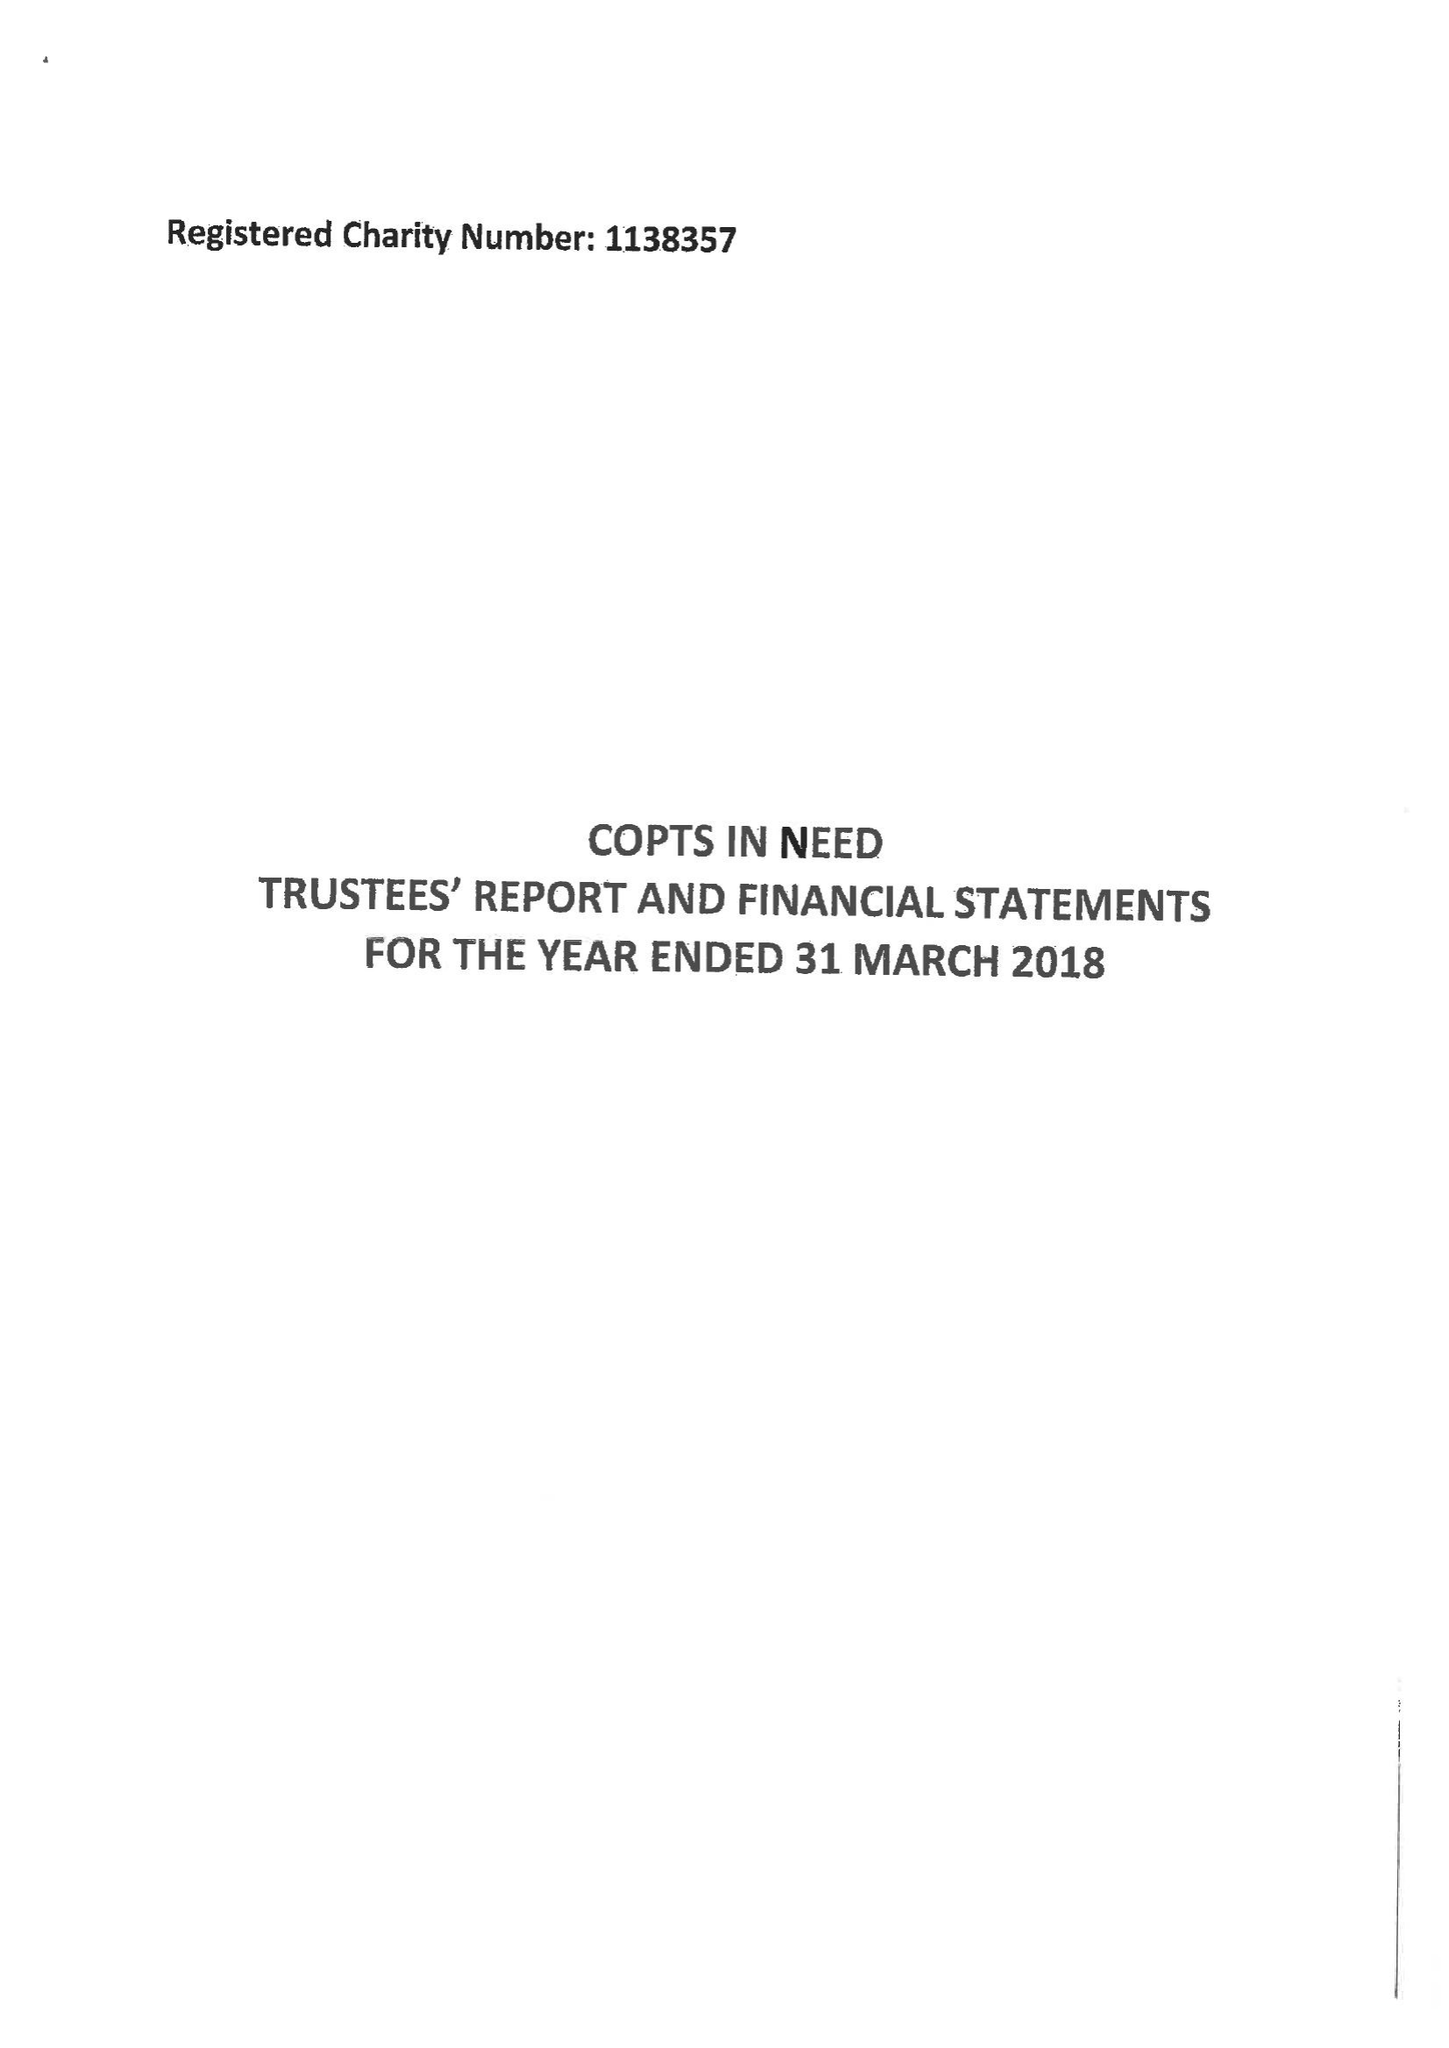What is the value for the report_date?
Answer the question using a single word or phrase. 2018-03-31 